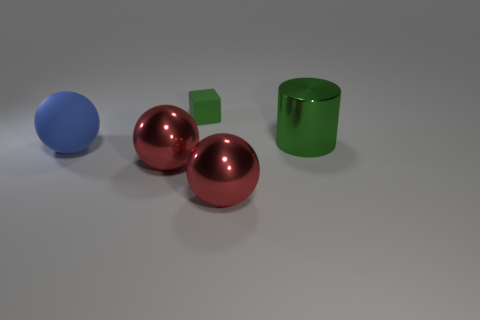There is a matte block; how many green cylinders are on the left side of it?
Ensure brevity in your answer.  0. What is the color of the matte thing behind the large metal cylinder that is on the right side of the small green rubber object?
Provide a short and direct response. Green. How many other objects are the same material as the large blue object?
Offer a terse response. 1. Are there the same number of things that are behind the blue matte sphere and big blue matte spheres?
Provide a succinct answer. No. There is a red thing on the right side of the red shiny thing on the left side of the rubber object that is behind the blue matte sphere; what is its material?
Keep it short and to the point. Metal. The matte thing that is in front of the green shiny cylinder is what color?
Offer a very short reply. Blue. Is there anything else that is the same shape as the small green matte object?
Give a very brief answer. No. There is a block that is behind the red shiny ball right of the tiny green matte thing; how big is it?
Offer a very short reply. Small. Is the number of big cylinders behind the big green cylinder the same as the number of red shiny objects to the right of the green matte thing?
Offer a terse response. No. Is there any other thing that has the same size as the green rubber thing?
Provide a succinct answer. No. 